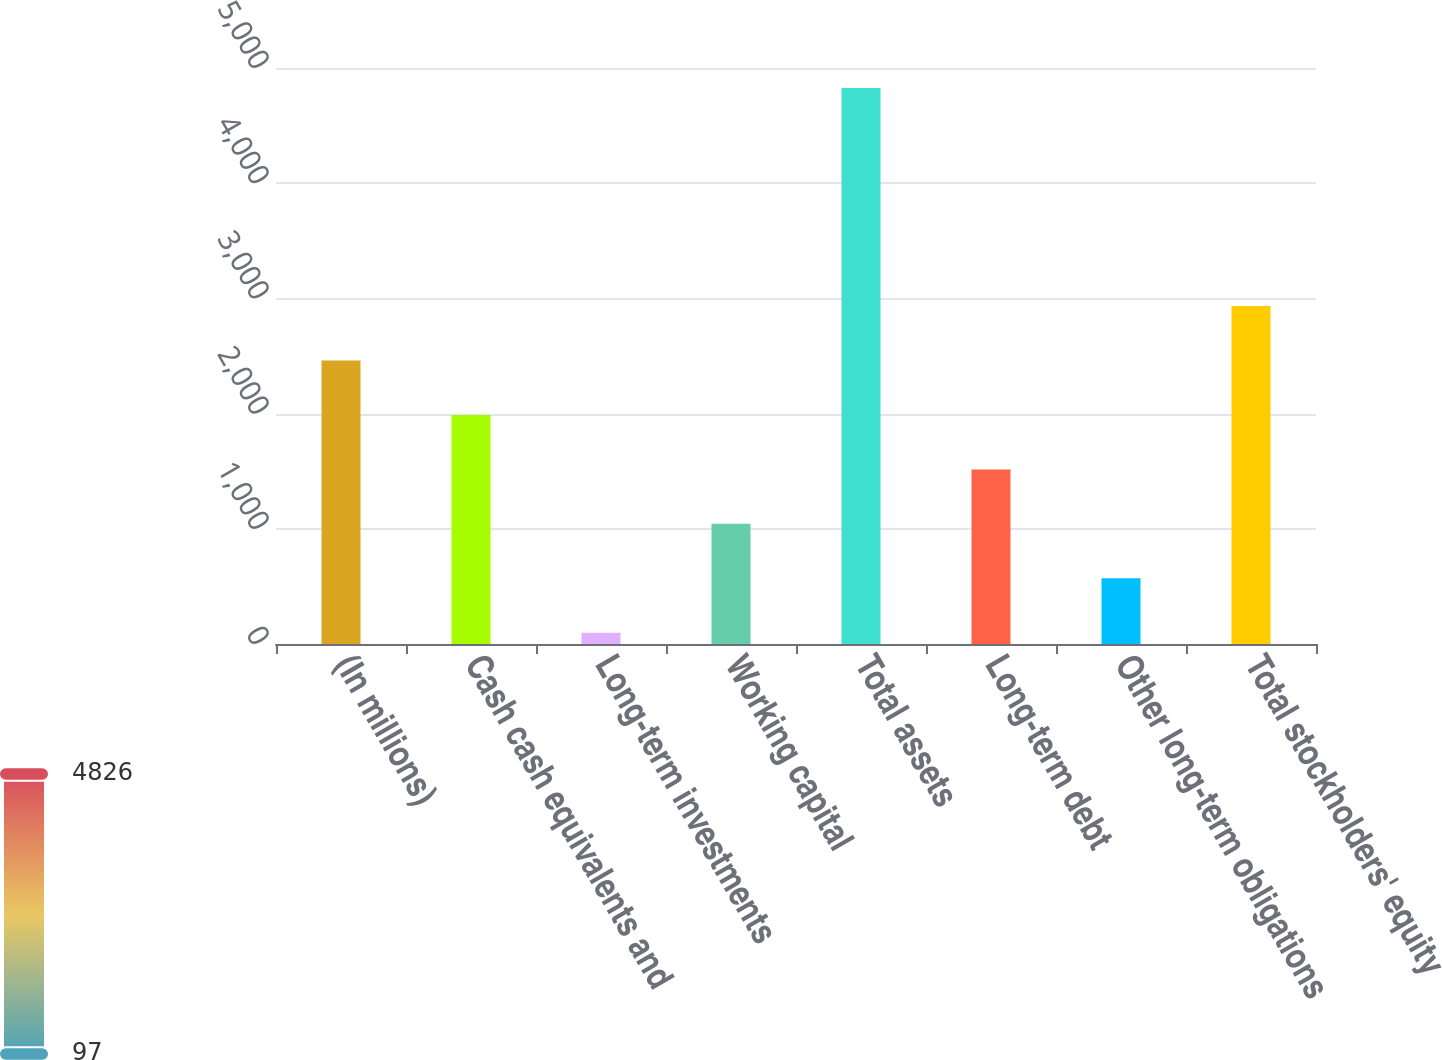<chart> <loc_0><loc_0><loc_500><loc_500><bar_chart><fcel>(In millions)<fcel>Cash cash equivalents and<fcel>Long-term investments<fcel>Working capital<fcel>Total assets<fcel>Long-term debt<fcel>Other long-term obligations<fcel>Total stockholders' equity<nl><fcel>2461.5<fcel>1988.6<fcel>97<fcel>1042.8<fcel>4826<fcel>1515.7<fcel>569.9<fcel>2934.4<nl></chart> 